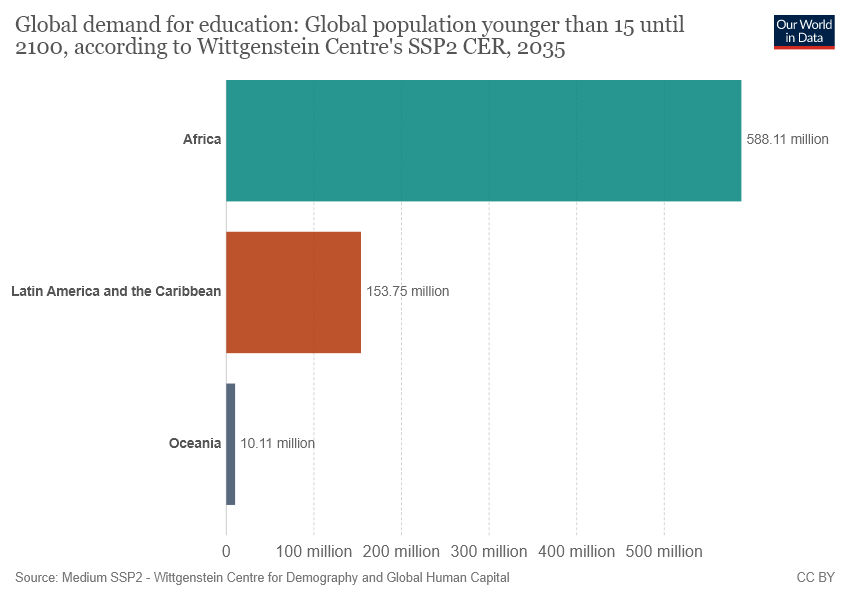Identify some key points in this picture. What is the difference between the largest and smallest bar? 578... The global population of Africa in the chart is 588.11. 